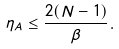<formula> <loc_0><loc_0><loc_500><loc_500>\eta _ { A } \leq \frac { 2 ( N - 1 ) } { \beta } .</formula> 